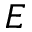<formula> <loc_0><loc_0><loc_500><loc_500>E</formula> 